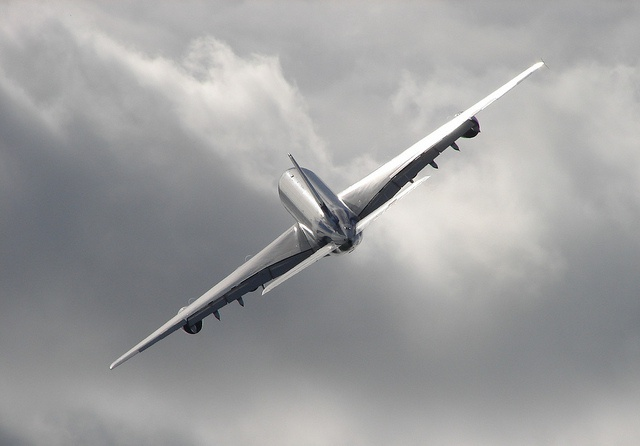Describe the objects in this image and their specific colors. I can see a airplane in darkgray, gray, white, and black tones in this image. 